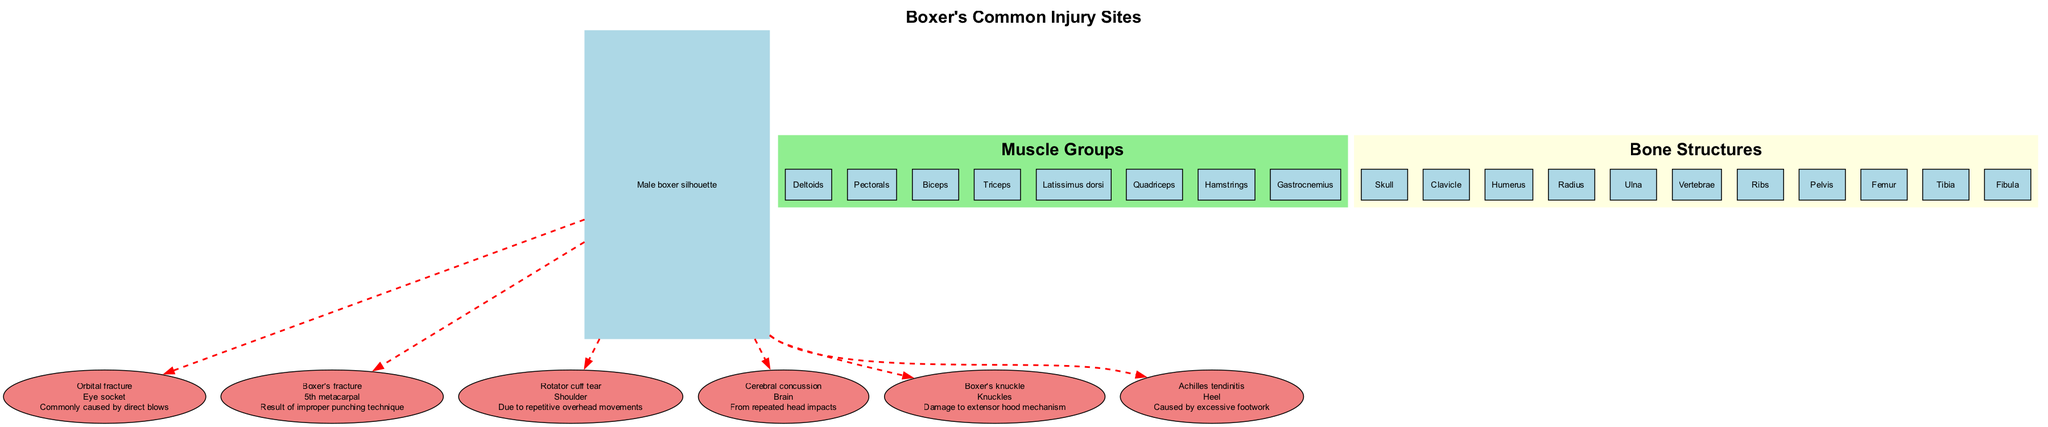What is the location of the Boxer's fracture? The diagram indicates that the Boxer's fracture is located at the 5th metacarpal. This is a direct association drawn from the specified injury site details.
Answer: 5th metacarpal How many injury sites are listed in the diagram? The diagram contains a total of six injury sites, as detailed under the injury site section. Each injury corresponds to a unique type of damage typically sustained by boxers.
Answer: 6 What is the common cause of an Orbital fracture? The diagram states that an Orbital fracture is commonly caused by direct blows. This information is explicitly mentioned in the description of the injury site.
Answer: Direct blows Which muscle group is located on the shoulder? The Rotator cuff tear is associated with the shoulder, which implies that the relevant muscle group for that location is the Deltoids, known to be involved in shoulder movement.
Answer: Deltoids What injury is linked to excessive footwork? According to the diagram's details, Achilles tendinitis is the injury connected to excessive footwork. The description specifies this cause for the injury site, providing a clear correlation.
Answer: Achilles tendinitis How many muscle groups are represented in the diagram? The diagram includes a total of eight muscle groups, as listed within the muscle groups section. This figure represents the major muscle areas relevant to a boxer's anatomy.
Answer: 8 What description is provided for cerebral concussion? The diagram describes cerebral concussion as resulting from repeated head impacts, reflecting the nature of this injury sustained by boxers through their career.
Answer: From repeated head impacts What type of injury does "Boxer's knuckle" refer to? The Boxer's knuckle refers to damage to the extensor hood mechanism. This description is tied directly to the associated injury site within the diagram.
Answer: Damage to extensor hood mechanism 